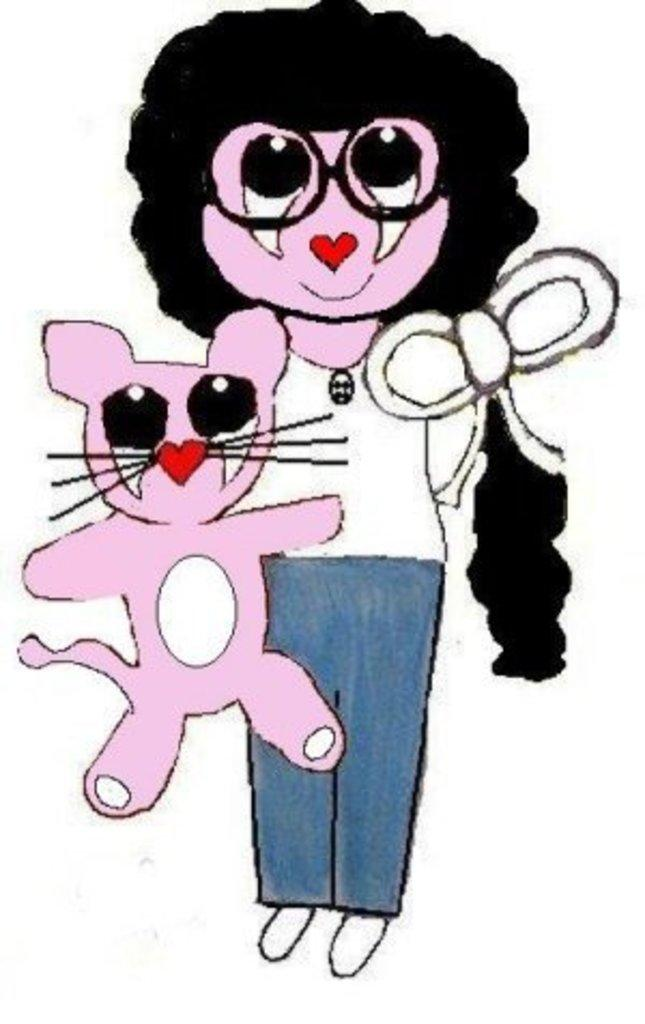Who or what is the main subject in the image? There is a person in the image. Are there any animals present in the image? Yes, there is a cat in the image. What else can be seen in the image besides the person and the cat? There are objects in the image. How would you describe the style of the image? The image appears to be a painting. What nation is represented by the cat in the image? The image does not depict a specific nation, and the cat is not associated with any particular nation. 